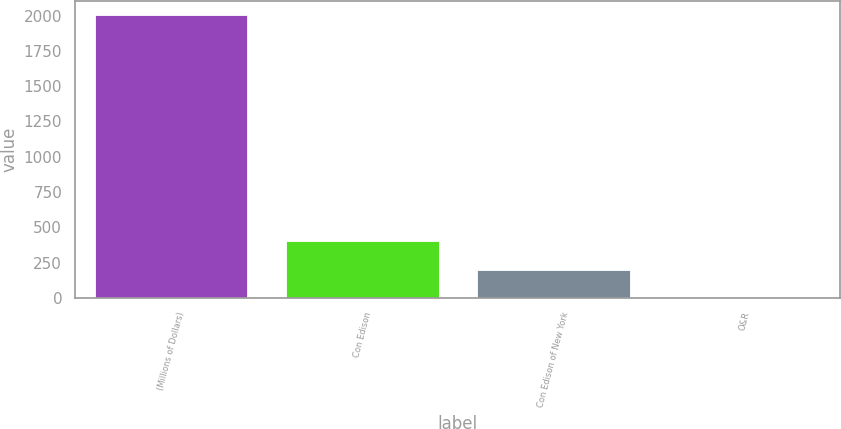Convert chart. <chart><loc_0><loc_0><loc_500><loc_500><bar_chart><fcel>(Millions of Dollars)<fcel>Con Edison<fcel>Con Edison of New York<fcel>O&R<nl><fcel>2002<fcel>401.2<fcel>201.1<fcel>1<nl></chart> 